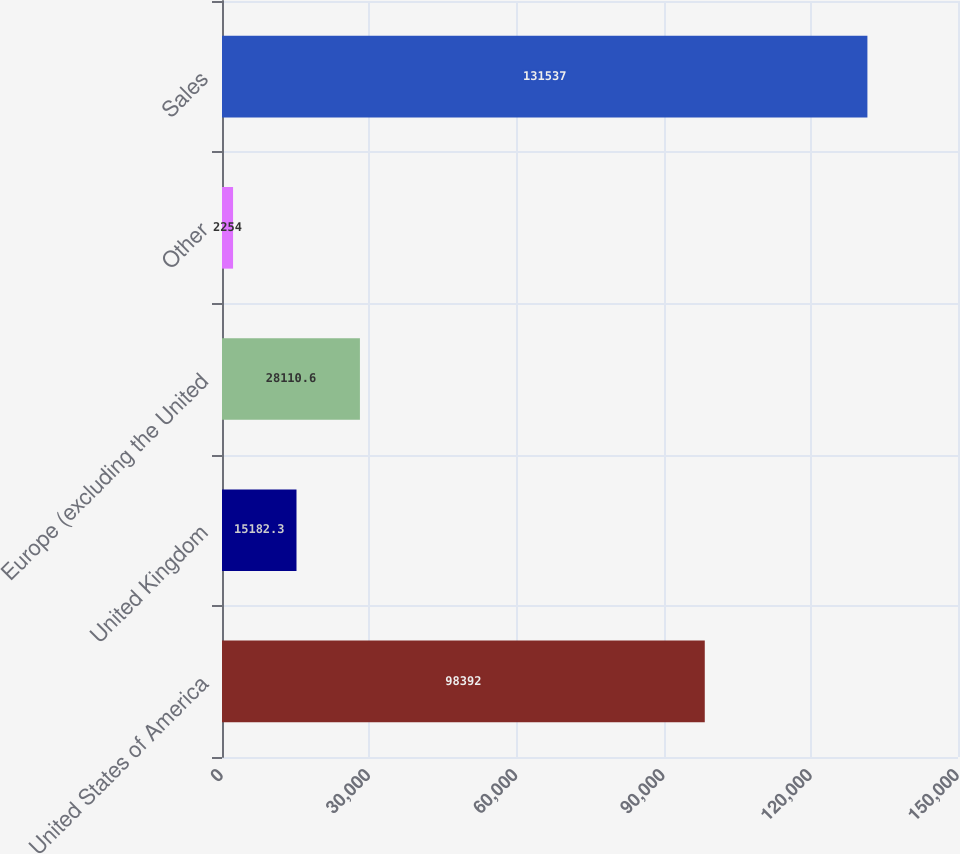Convert chart to OTSL. <chart><loc_0><loc_0><loc_500><loc_500><bar_chart><fcel>United States of America<fcel>United Kingdom<fcel>Europe (excluding the United<fcel>Other<fcel>Sales<nl><fcel>98392<fcel>15182.3<fcel>28110.6<fcel>2254<fcel>131537<nl></chart> 